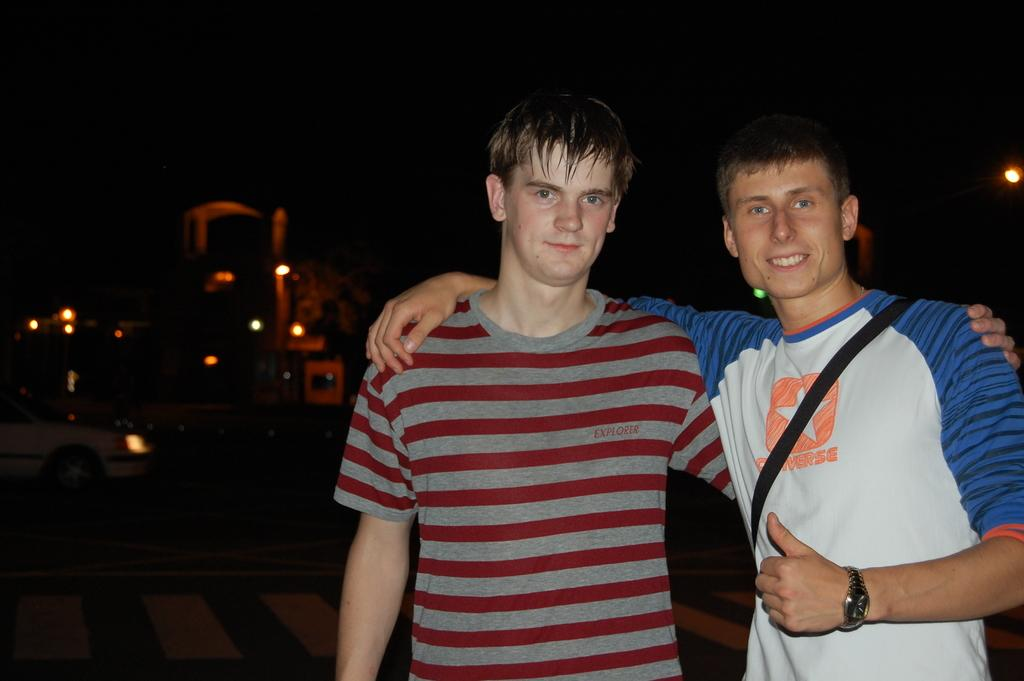Provide a one-sentence caption for the provided image. A young man wearing a Converse shirt has his arm around his friend. 